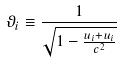<formula> <loc_0><loc_0><loc_500><loc_500>\vartheta _ { i } \equiv \frac { 1 } { \sqrt { 1 - \frac { u _ { i } + u _ { i } } { c ^ { 2 } } } }</formula> 